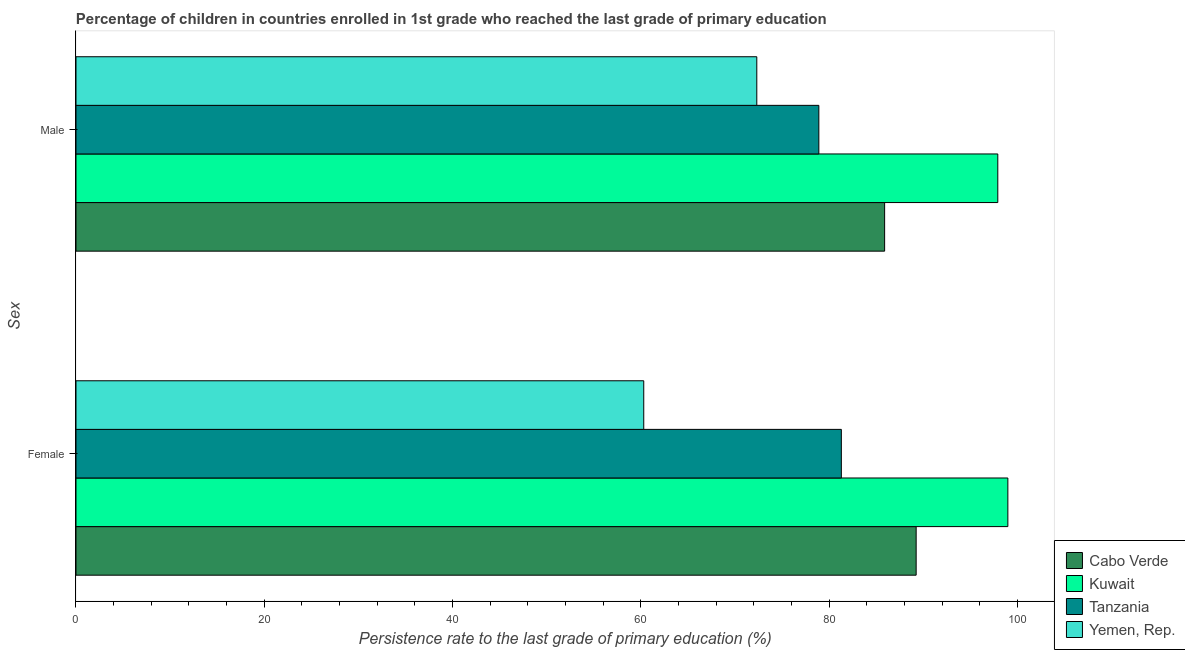Are the number of bars per tick equal to the number of legend labels?
Your answer should be very brief. Yes. How many bars are there on the 2nd tick from the bottom?
Provide a succinct answer. 4. What is the label of the 2nd group of bars from the top?
Offer a very short reply. Female. What is the persistence rate of female students in Tanzania?
Your answer should be compact. 81.28. Across all countries, what is the maximum persistence rate of female students?
Provide a succinct answer. 98.96. Across all countries, what is the minimum persistence rate of male students?
Make the answer very short. 72.3. In which country was the persistence rate of male students maximum?
Your answer should be compact. Kuwait. In which country was the persistence rate of male students minimum?
Keep it short and to the point. Yemen, Rep. What is the total persistence rate of female students in the graph?
Give a very brief answer. 329.75. What is the difference between the persistence rate of male students in Tanzania and that in Cabo Verde?
Provide a succinct answer. -6.99. What is the difference between the persistence rate of female students in Cabo Verde and the persistence rate of male students in Kuwait?
Offer a terse response. -8.67. What is the average persistence rate of male students per country?
Keep it short and to the point. 83.74. What is the difference between the persistence rate of male students and persistence rate of female students in Kuwait?
Your response must be concise. -1.07. In how many countries, is the persistence rate of female students greater than 32 %?
Provide a short and direct response. 4. What is the ratio of the persistence rate of female students in Yemen, Rep. to that in Tanzania?
Your answer should be very brief. 0.74. What does the 2nd bar from the top in Female represents?
Give a very brief answer. Tanzania. What does the 2nd bar from the bottom in Female represents?
Keep it short and to the point. Kuwait. How many countries are there in the graph?
Your answer should be compact. 4. Does the graph contain any zero values?
Offer a very short reply. No. Does the graph contain grids?
Your response must be concise. No. Where does the legend appear in the graph?
Your answer should be compact. Bottom right. How many legend labels are there?
Give a very brief answer. 4. What is the title of the graph?
Your response must be concise. Percentage of children in countries enrolled in 1st grade who reached the last grade of primary education. What is the label or title of the X-axis?
Your answer should be very brief. Persistence rate to the last grade of primary education (%). What is the label or title of the Y-axis?
Give a very brief answer. Sex. What is the Persistence rate to the last grade of primary education (%) in Cabo Verde in Female?
Your answer should be compact. 89.22. What is the Persistence rate to the last grade of primary education (%) in Kuwait in Female?
Your answer should be very brief. 98.96. What is the Persistence rate to the last grade of primary education (%) of Tanzania in Female?
Keep it short and to the point. 81.28. What is the Persistence rate to the last grade of primary education (%) of Yemen, Rep. in Female?
Keep it short and to the point. 60.29. What is the Persistence rate to the last grade of primary education (%) of Cabo Verde in Male?
Keep it short and to the point. 85.87. What is the Persistence rate to the last grade of primary education (%) in Kuwait in Male?
Provide a succinct answer. 97.89. What is the Persistence rate to the last grade of primary education (%) in Tanzania in Male?
Ensure brevity in your answer.  78.89. What is the Persistence rate to the last grade of primary education (%) of Yemen, Rep. in Male?
Give a very brief answer. 72.3. Across all Sex, what is the maximum Persistence rate to the last grade of primary education (%) of Cabo Verde?
Ensure brevity in your answer.  89.22. Across all Sex, what is the maximum Persistence rate to the last grade of primary education (%) of Kuwait?
Provide a succinct answer. 98.96. Across all Sex, what is the maximum Persistence rate to the last grade of primary education (%) in Tanzania?
Your response must be concise. 81.28. Across all Sex, what is the maximum Persistence rate to the last grade of primary education (%) in Yemen, Rep.?
Your answer should be compact. 72.3. Across all Sex, what is the minimum Persistence rate to the last grade of primary education (%) in Cabo Verde?
Provide a succinct answer. 85.87. Across all Sex, what is the minimum Persistence rate to the last grade of primary education (%) in Kuwait?
Give a very brief answer. 97.89. Across all Sex, what is the minimum Persistence rate to the last grade of primary education (%) in Tanzania?
Your answer should be compact. 78.89. Across all Sex, what is the minimum Persistence rate to the last grade of primary education (%) in Yemen, Rep.?
Keep it short and to the point. 60.29. What is the total Persistence rate to the last grade of primary education (%) in Cabo Verde in the graph?
Give a very brief answer. 175.09. What is the total Persistence rate to the last grade of primary education (%) of Kuwait in the graph?
Offer a terse response. 196.85. What is the total Persistence rate to the last grade of primary education (%) in Tanzania in the graph?
Provide a succinct answer. 160.16. What is the total Persistence rate to the last grade of primary education (%) in Yemen, Rep. in the graph?
Your answer should be very brief. 132.59. What is the difference between the Persistence rate to the last grade of primary education (%) in Cabo Verde in Female and that in Male?
Your response must be concise. 3.35. What is the difference between the Persistence rate to the last grade of primary education (%) in Kuwait in Female and that in Male?
Your response must be concise. 1.07. What is the difference between the Persistence rate to the last grade of primary education (%) of Tanzania in Female and that in Male?
Your answer should be very brief. 2.39. What is the difference between the Persistence rate to the last grade of primary education (%) of Yemen, Rep. in Female and that in Male?
Keep it short and to the point. -12. What is the difference between the Persistence rate to the last grade of primary education (%) in Cabo Verde in Female and the Persistence rate to the last grade of primary education (%) in Kuwait in Male?
Ensure brevity in your answer.  -8.67. What is the difference between the Persistence rate to the last grade of primary education (%) of Cabo Verde in Female and the Persistence rate to the last grade of primary education (%) of Tanzania in Male?
Give a very brief answer. 10.33. What is the difference between the Persistence rate to the last grade of primary education (%) in Cabo Verde in Female and the Persistence rate to the last grade of primary education (%) in Yemen, Rep. in Male?
Ensure brevity in your answer.  16.92. What is the difference between the Persistence rate to the last grade of primary education (%) of Kuwait in Female and the Persistence rate to the last grade of primary education (%) of Tanzania in Male?
Provide a succinct answer. 20.07. What is the difference between the Persistence rate to the last grade of primary education (%) of Kuwait in Female and the Persistence rate to the last grade of primary education (%) of Yemen, Rep. in Male?
Offer a very short reply. 26.66. What is the difference between the Persistence rate to the last grade of primary education (%) of Tanzania in Female and the Persistence rate to the last grade of primary education (%) of Yemen, Rep. in Male?
Ensure brevity in your answer.  8.98. What is the average Persistence rate to the last grade of primary education (%) in Cabo Verde per Sex?
Provide a succinct answer. 87.55. What is the average Persistence rate to the last grade of primary education (%) in Kuwait per Sex?
Give a very brief answer. 98.42. What is the average Persistence rate to the last grade of primary education (%) of Tanzania per Sex?
Offer a terse response. 80.08. What is the average Persistence rate to the last grade of primary education (%) in Yemen, Rep. per Sex?
Your answer should be very brief. 66.3. What is the difference between the Persistence rate to the last grade of primary education (%) in Cabo Verde and Persistence rate to the last grade of primary education (%) in Kuwait in Female?
Provide a short and direct response. -9.74. What is the difference between the Persistence rate to the last grade of primary education (%) of Cabo Verde and Persistence rate to the last grade of primary education (%) of Tanzania in Female?
Your answer should be very brief. 7.94. What is the difference between the Persistence rate to the last grade of primary education (%) of Cabo Verde and Persistence rate to the last grade of primary education (%) of Yemen, Rep. in Female?
Make the answer very short. 28.93. What is the difference between the Persistence rate to the last grade of primary education (%) of Kuwait and Persistence rate to the last grade of primary education (%) of Tanzania in Female?
Your response must be concise. 17.68. What is the difference between the Persistence rate to the last grade of primary education (%) of Kuwait and Persistence rate to the last grade of primary education (%) of Yemen, Rep. in Female?
Keep it short and to the point. 38.67. What is the difference between the Persistence rate to the last grade of primary education (%) of Tanzania and Persistence rate to the last grade of primary education (%) of Yemen, Rep. in Female?
Offer a terse response. 20.98. What is the difference between the Persistence rate to the last grade of primary education (%) in Cabo Verde and Persistence rate to the last grade of primary education (%) in Kuwait in Male?
Offer a very short reply. -12.02. What is the difference between the Persistence rate to the last grade of primary education (%) of Cabo Verde and Persistence rate to the last grade of primary education (%) of Tanzania in Male?
Your response must be concise. 6.99. What is the difference between the Persistence rate to the last grade of primary education (%) of Cabo Verde and Persistence rate to the last grade of primary education (%) of Yemen, Rep. in Male?
Offer a very short reply. 13.57. What is the difference between the Persistence rate to the last grade of primary education (%) of Kuwait and Persistence rate to the last grade of primary education (%) of Tanzania in Male?
Offer a terse response. 19. What is the difference between the Persistence rate to the last grade of primary education (%) of Kuwait and Persistence rate to the last grade of primary education (%) of Yemen, Rep. in Male?
Provide a short and direct response. 25.59. What is the difference between the Persistence rate to the last grade of primary education (%) of Tanzania and Persistence rate to the last grade of primary education (%) of Yemen, Rep. in Male?
Offer a very short reply. 6.59. What is the ratio of the Persistence rate to the last grade of primary education (%) of Cabo Verde in Female to that in Male?
Your answer should be compact. 1.04. What is the ratio of the Persistence rate to the last grade of primary education (%) in Kuwait in Female to that in Male?
Your answer should be compact. 1.01. What is the ratio of the Persistence rate to the last grade of primary education (%) in Tanzania in Female to that in Male?
Your answer should be compact. 1.03. What is the ratio of the Persistence rate to the last grade of primary education (%) in Yemen, Rep. in Female to that in Male?
Keep it short and to the point. 0.83. What is the difference between the highest and the second highest Persistence rate to the last grade of primary education (%) of Cabo Verde?
Give a very brief answer. 3.35. What is the difference between the highest and the second highest Persistence rate to the last grade of primary education (%) of Kuwait?
Offer a very short reply. 1.07. What is the difference between the highest and the second highest Persistence rate to the last grade of primary education (%) of Tanzania?
Offer a terse response. 2.39. What is the difference between the highest and the second highest Persistence rate to the last grade of primary education (%) in Yemen, Rep.?
Provide a short and direct response. 12. What is the difference between the highest and the lowest Persistence rate to the last grade of primary education (%) in Cabo Verde?
Keep it short and to the point. 3.35. What is the difference between the highest and the lowest Persistence rate to the last grade of primary education (%) of Kuwait?
Your answer should be very brief. 1.07. What is the difference between the highest and the lowest Persistence rate to the last grade of primary education (%) in Tanzania?
Your answer should be compact. 2.39. What is the difference between the highest and the lowest Persistence rate to the last grade of primary education (%) in Yemen, Rep.?
Make the answer very short. 12. 